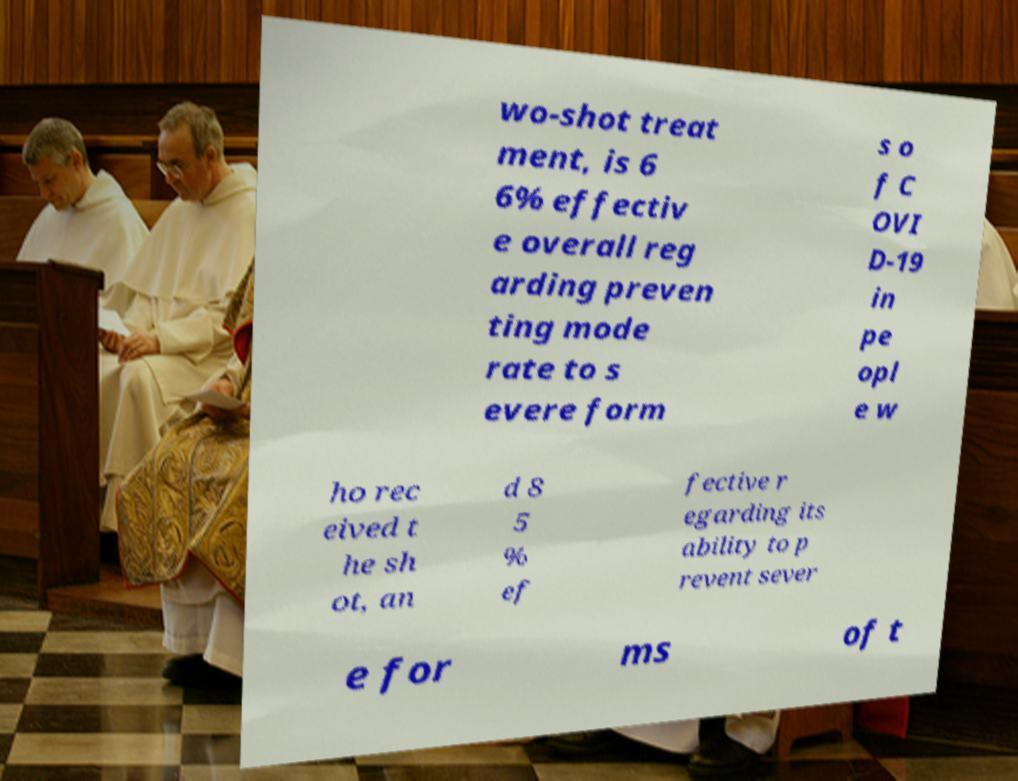Could you assist in decoding the text presented in this image and type it out clearly? wo-shot treat ment, is 6 6% effectiv e overall reg arding preven ting mode rate to s evere form s o f C OVI D-19 in pe opl e w ho rec eived t he sh ot, an d 8 5 % ef fective r egarding its ability to p revent sever e for ms of t 